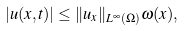<formula> <loc_0><loc_0><loc_500><loc_500>| u ( x , t ) | \leq \| u _ { x } \| _ { L ^ { \infty } ( \Omega ) } \omega ( x ) ,</formula> 